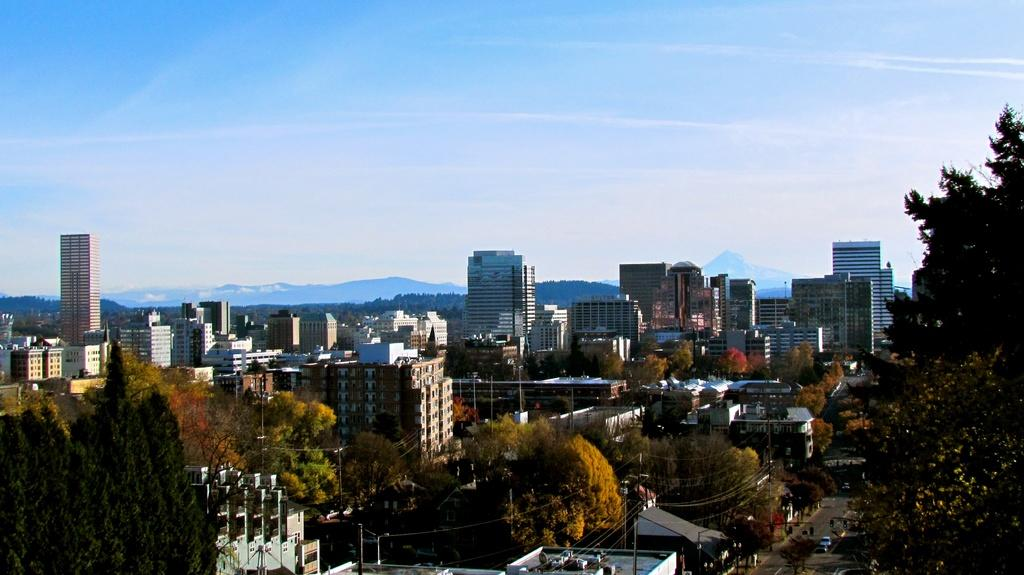What type of view is shown in the image? The image is an outside view. What can be seen at the bottom of the image? There are many trees and buildings at the bottom of the image. What is present on the right side of the image? There are vehicles on the road on the right side of the image. What is visible at the top of the image? The sky is visible at the top of the image. What grade of stick can be seen in the image? There is no stick present in the image. How low are the trees in the image? The image does not provide information about the height of the trees, only that they are visible at the bottom of the image. 